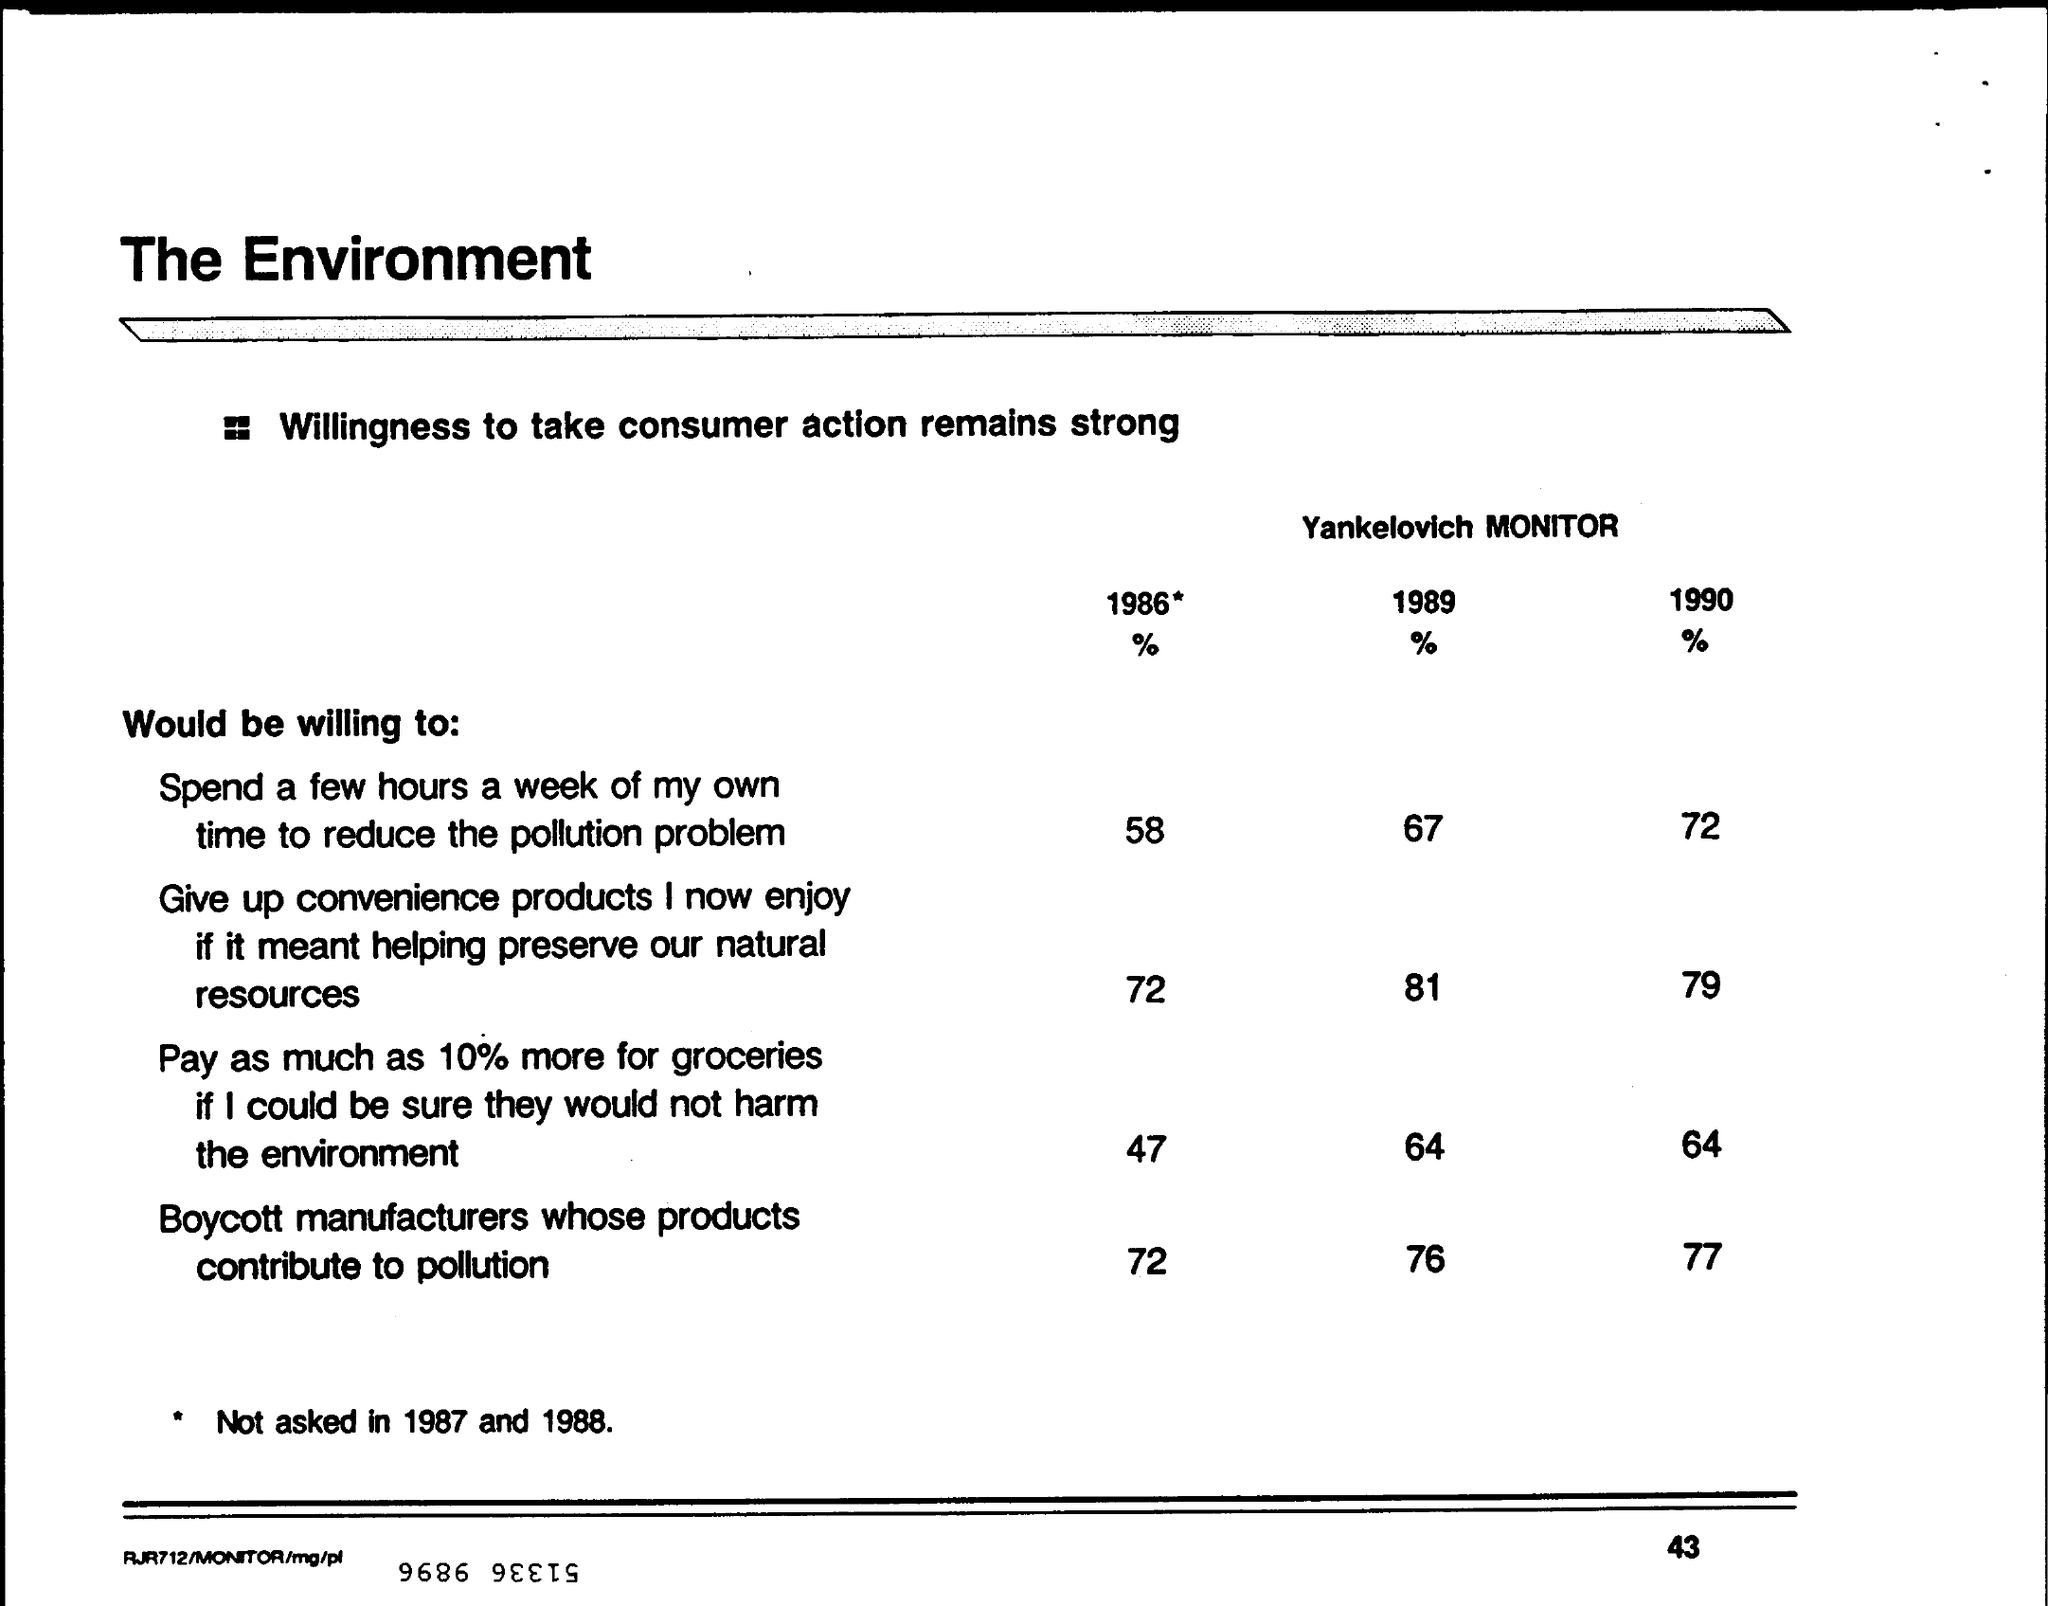Identify some key points in this picture. In the year 1990, 77% of manufacturers involved in a boycott contributed to pollution through their products. It is estimated that 72% of consumers in 1990 would be willing to dedicate a few hours of their own time per week to help reduce pollution levels. In 1989, 76% of boycott manufacturers whose products contributed to pollution. According to a survey conducted in 1989, a significant percentage of consumers were willing to dedicate a few hours of their own time each week to help reduce pollution. 